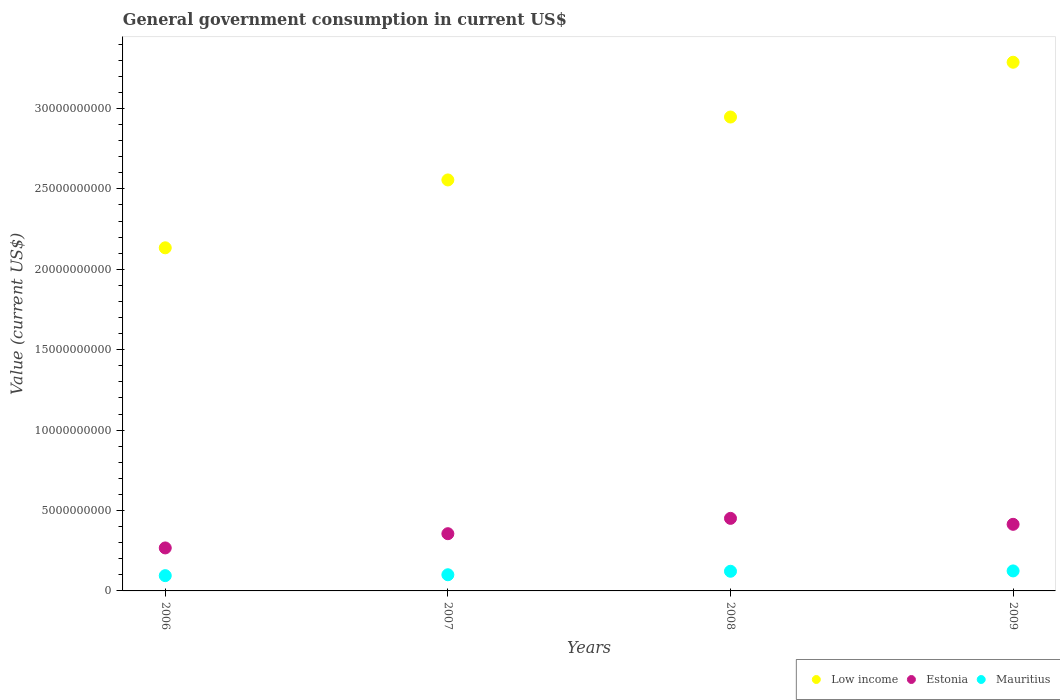Is the number of dotlines equal to the number of legend labels?
Your response must be concise. Yes. What is the government conusmption in Estonia in 2009?
Provide a short and direct response. 4.14e+09. Across all years, what is the maximum government conusmption in Mauritius?
Ensure brevity in your answer.  1.24e+09. Across all years, what is the minimum government conusmption in Estonia?
Provide a succinct answer. 2.67e+09. In which year was the government conusmption in Estonia maximum?
Provide a succinct answer. 2008. What is the total government conusmption in Mauritius in the graph?
Keep it short and to the point. 4.42e+09. What is the difference between the government conusmption in Mauritius in 2007 and that in 2009?
Offer a very short reply. -2.38e+08. What is the difference between the government conusmption in Mauritius in 2006 and the government conusmption in Low income in 2009?
Offer a terse response. -3.19e+1. What is the average government conusmption in Low income per year?
Keep it short and to the point. 2.73e+1. In the year 2006, what is the difference between the government conusmption in Estonia and government conusmption in Low income?
Offer a very short reply. -1.87e+1. What is the ratio of the government conusmption in Estonia in 2007 to that in 2009?
Keep it short and to the point. 0.86. Is the government conusmption in Estonia in 2007 less than that in 2009?
Provide a succinct answer. Yes. What is the difference between the highest and the second highest government conusmption in Estonia?
Make the answer very short. 3.70e+08. What is the difference between the highest and the lowest government conusmption in Estonia?
Give a very brief answer. 1.84e+09. In how many years, is the government conusmption in Low income greater than the average government conusmption in Low income taken over all years?
Provide a short and direct response. 2. Is the sum of the government conusmption in Estonia in 2008 and 2009 greater than the maximum government conusmption in Low income across all years?
Ensure brevity in your answer.  No. Is it the case that in every year, the sum of the government conusmption in Estonia and government conusmption in Low income  is greater than the government conusmption in Mauritius?
Your answer should be compact. Yes. Does the government conusmption in Low income monotonically increase over the years?
Make the answer very short. Yes. How many dotlines are there?
Provide a succinct answer. 3. How many years are there in the graph?
Make the answer very short. 4. How are the legend labels stacked?
Ensure brevity in your answer.  Horizontal. What is the title of the graph?
Offer a very short reply. General government consumption in current US$. What is the label or title of the X-axis?
Your answer should be very brief. Years. What is the label or title of the Y-axis?
Provide a succinct answer. Value (current US$). What is the Value (current US$) of Low income in 2006?
Provide a short and direct response. 2.13e+1. What is the Value (current US$) of Estonia in 2006?
Your answer should be very brief. 2.67e+09. What is the Value (current US$) of Mauritius in 2006?
Offer a terse response. 9.50e+08. What is the Value (current US$) of Low income in 2007?
Your answer should be compact. 2.56e+1. What is the Value (current US$) in Estonia in 2007?
Your response must be concise. 3.56e+09. What is the Value (current US$) of Mauritius in 2007?
Give a very brief answer. 1.01e+09. What is the Value (current US$) in Low income in 2008?
Keep it short and to the point. 2.95e+1. What is the Value (current US$) in Estonia in 2008?
Provide a succinct answer. 4.51e+09. What is the Value (current US$) of Mauritius in 2008?
Offer a very short reply. 1.22e+09. What is the Value (current US$) of Low income in 2009?
Offer a very short reply. 3.29e+1. What is the Value (current US$) of Estonia in 2009?
Keep it short and to the point. 4.14e+09. What is the Value (current US$) of Mauritius in 2009?
Offer a very short reply. 1.24e+09. Across all years, what is the maximum Value (current US$) in Low income?
Provide a short and direct response. 3.29e+1. Across all years, what is the maximum Value (current US$) of Estonia?
Keep it short and to the point. 4.51e+09. Across all years, what is the maximum Value (current US$) of Mauritius?
Make the answer very short. 1.24e+09. Across all years, what is the minimum Value (current US$) of Low income?
Make the answer very short. 2.13e+1. Across all years, what is the minimum Value (current US$) in Estonia?
Your answer should be compact. 2.67e+09. Across all years, what is the minimum Value (current US$) in Mauritius?
Ensure brevity in your answer.  9.50e+08. What is the total Value (current US$) of Low income in the graph?
Provide a short and direct response. 1.09e+11. What is the total Value (current US$) in Estonia in the graph?
Give a very brief answer. 1.49e+1. What is the total Value (current US$) of Mauritius in the graph?
Keep it short and to the point. 4.42e+09. What is the difference between the Value (current US$) in Low income in 2006 and that in 2007?
Your answer should be very brief. -4.22e+09. What is the difference between the Value (current US$) of Estonia in 2006 and that in 2007?
Make the answer very short. -8.85e+08. What is the difference between the Value (current US$) of Mauritius in 2006 and that in 2007?
Ensure brevity in your answer.  -5.57e+07. What is the difference between the Value (current US$) of Low income in 2006 and that in 2008?
Your response must be concise. -8.13e+09. What is the difference between the Value (current US$) in Estonia in 2006 and that in 2008?
Ensure brevity in your answer.  -1.84e+09. What is the difference between the Value (current US$) in Mauritius in 2006 and that in 2008?
Make the answer very short. -2.73e+08. What is the difference between the Value (current US$) in Low income in 2006 and that in 2009?
Your answer should be compact. -1.15e+1. What is the difference between the Value (current US$) in Estonia in 2006 and that in 2009?
Make the answer very short. -1.47e+09. What is the difference between the Value (current US$) of Mauritius in 2006 and that in 2009?
Give a very brief answer. -2.94e+08. What is the difference between the Value (current US$) in Low income in 2007 and that in 2008?
Keep it short and to the point. -3.91e+09. What is the difference between the Value (current US$) in Estonia in 2007 and that in 2008?
Provide a short and direct response. -9.54e+08. What is the difference between the Value (current US$) in Mauritius in 2007 and that in 2008?
Offer a terse response. -2.17e+08. What is the difference between the Value (current US$) of Low income in 2007 and that in 2009?
Give a very brief answer. -7.32e+09. What is the difference between the Value (current US$) in Estonia in 2007 and that in 2009?
Your answer should be very brief. -5.83e+08. What is the difference between the Value (current US$) of Mauritius in 2007 and that in 2009?
Provide a short and direct response. -2.38e+08. What is the difference between the Value (current US$) of Low income in 2008 and that in 2009?
Your response must be concise. -3.41e+09. What is the difference between the Value (current US$) in Estonia in 2008 and that in 2009?
Ensure brevity in your answer.  3.70e+08. What is the difference between the Value (current US$) in Mauritius in 2008 and that in 2009?
Provide a succinct answer. -2.11e+07. What is the difference between the Value (current US$) in Low income in 2006 and the Value (current US$) in Estonia in 2007?
Your answer should be compact. 1.78e+1. What is the difference between the Value (current US$) of Low income in 2006 and the Value (current US$) of Mauritius in 2007?
Your answer should be compact. 2.03e+1. What is the difference between the Value (current US$) of Estonia in 2006 and the Value (current US$) of Mauritius in 2007?
Give a very brief answer. 1.67e+09. What is the difference between the Value (current US$) in Low income in 2006 and the Value (current US$) in Estonia in 2008?
Provide a succinct answer. 1.68e+1. What is the difference between the Value (current US$) in Low income in 2006 and the Value (current US$) in Mauritius in 2008?
Keep it short and to the point. 2.01e+1. What is the difference between the Value (current US$) in Estonia in 2006 and the Value (current US$) in Mauritius in 2008?
Provide a succinct answer. 1.45e+09. What is the difference between the Value (current US$) in Low income in 2006 and the Value (current US$) in Estonia in 2009?
Give a very brief answer. 1.72e+1. What is the difference between the Value (current US$) of Low income in 2006 and the Value (current US$) of Mauritius in 2009?
Your answer should be very brief. 2.01e+1. What is the difference between the Value (current US$) in Estonia in 2006 and the Value (current US$) in Mauritius in 2009?
Your answer should be compact. 1.43e+09. What is the difference between the Value (current US$) in Low income in 2007 and the Value (current US$) in Estonia in 2008?
Make the answer very short. 2.10e+1. What is the difference between the Value (current US$) of Low income in 2007 and the Value (current US$) of Mauritius in 2008?
Your response must be concise. 2.43e+1. What is the difference between the Value (current US$) of Estonia in 2007 and the Value (current US$) of Mauritius in 2008?
Your answer should be very brief. 2.34e+09. What is the difference between the Value (current US$) in Low income in 2007 and the Value (current US$) in Estonia in 2009?
Your response must be concise. 2.14e+1. What is the difference between the Value (current US$) in Low income in 2007 and the Value (current US$) in Mauritius in 2009?
Offer a terse response. 2.43e+1. What is the difference between the Value (current US$) of Estonia in 2007 and the Value (current US$) of Mauritius in 2009?
Provide a short and direct response. 2.31e+09. What is the difference between the Value (current US$) in Low income in 2008 and the Value (current US$) in Estonia in 2009?
Give a very brief answer. 2.53e+1. What is the difference between the Value (current US$) in Low income in 2008 and the Value (current US$) in Mauritius in 2009?
Keep it short and to the point. 2.82e+1. What is the difference between the Value (current US$) of Estonia in 2008 and the Value (current US$) of Mauritius in 2009?
Offer a very short reply. 3.27e+09. What is the average Value (current US$) in Low income per year?
Offer a very short reply. 2.73e+1. What is the average Value (current US$) of Estonia per year?
Provide a short and direct response. 3.72e+09. What is the average Value (current US$) in Mauritius per year?
Offer a very short reply. 1.11e+09. In the year 2006, what is the difference between the Value (current US$) in Low income and Value (current US$) in Estonia?
Your answer should be compact. 1.87e+1. In the year 2006, what is the difference between the Value (current US$) of Low income and Value (current US$) of Mauritius?
Keep it short and to the point. 2.04e+1. In the year 2006, what is the difference between the Value (current US$) in Estonia and Value (current US$) in Mauritius?
Keep it short and to the point. 1.72e+09. In the year 2007, what is the difference between the Value (current US$) in Low income and Value (current US$) in Estonia?
Offer a very short reply. 2.20e+1. In the year 2007, what is the difference between the Value (current US$) of Low income and Value (current US$) of Mauritius?
Keep it short and to the point. 2.46e+1. In the year 2007, what is the difference between the Value (current US$) in Estonia and Value (current US$) in Mauritius?
Your answer should be very brief. 2.55e+09. In the year 2008, what is the difference between the Value (current US$) in Low income and Value (current US$) in Estonia?
Give a very brief answer. 2.50e+1. In the year 2008, what is the difference between the Value (current US$) of Low income and Value (current US$) of Mauritius?
Keep it short and to the point. 2.82e+1. In the year 2008, what is the difference between the Value (current US$) of Estonia and Value (current US$) of Mauritius?
Your answer should be very brief. 3.29e+09. In the year 2009, what is the difference between the Value (current US$) in Low income and Value (current US$) in Estonia?
Your answer should be compact. 2.87e+1. In the year 2009, what is the difference between the Value (current US$) of Low income and Value (current US$) of Mauritius?
Provide a succinct answer. 3.16e+1. In the year 2009, what is the difference between the Value (current US$) of Estonia and Value (current US$) of Mauritius?
Ensure brevity in your answer.  2.90e+09. What is the ratio of the Value (current US$) in Low income in 2006 to that in 2007?
Your answer should be very brief. 0.83. What is the ratio of the Value (current US$) of Estonia in 2006 to that in 2007?
Provide a succinct answer. 0.75. What is the ratio of the Value (current US$) in Mauritius in 2006 to that in 2007?
Make the answer very short. 0.94. What is the ratio of the Value (current US$) of Low income in 2006 to that in 2008?
Provide a succinct answer. 0.72. What is the ratio of the Value (current US$) of Estonia in 2006 to that in 2008?
Ensure brevity in your answer.  0.59. What is the ratio of the Value (current US$) in Mauritius in 2006 to that in 2008?
Provide a succinct answer. 0.78. What is the ratio of the Value (current US$) in Low income in 2006 to that in 2009?
Make the answer very short. 0.65. What is the ratio of the Value (current US$) in Estonia in 2006 to that in 2009?
Offer a very short reply. 0.65. What is the ratio of the Value (current US$) in Mauritius in 2006 to that in 2009?
Your answer should be very brief. 0.76. What is the ratio of the Value (current US$) in Low income in 2007 to that in 2008?
Provide a succinct answer. 0.87. What is the ratio of the Value (current US$) of Estonia in 2007 to that in 2008?
Provide a succinct answer. 0.79. What is the ratio of the Value (current US$) of Mauritius in 2007 to that in 2008?
Offer a terse response. 0.82. What is the ratio of the Value (current US$) in Low income in 2007 to that in 2009?
Provide a short and direct response. 0.78. What is the ratio of the Value (current US$) of Estonia in 2007 to that in 2009?
Provide a short and direct response. 0.86. What is the ratio of the Value (current US$) of Mauritius in 2007 to that in 2009?
Keep it short and to the point. 0.81. What is the ratio of the Value (current US$) in Low income in 2008 to that in 2009?
Give a very brief answer. 0.9. What is the ratio of the Value (current US$) in Estonia in 2008 to that in 2009?
Offer a terse response. 1.09. What is the difference between the highest and the second highest Value (current US$) in Low income?
Ensure brevity in your answer.  3.41e+09. What is the difference between the highest and the second highest Value (current US$) in Estonia?
Provide a succinct answer. 3.70e+08. What is the difference between the highest and the second highest Value (current US$) of Mauritius?
Provide a short and direct response. 2.11e+07. What is the difference between the highest and the lowest Value (current US$) of Low income?
Ensure brevity in your answer.  1.15e+1. What is the difference between the highest and the lowest Value (current US$) of Estonia?
Provide a succinct answer. 1.84e+09. What is the difference between the highest and the lowest Value (current US$) of Mauritius?
Keep it short and to the point. 2.94e+08. 